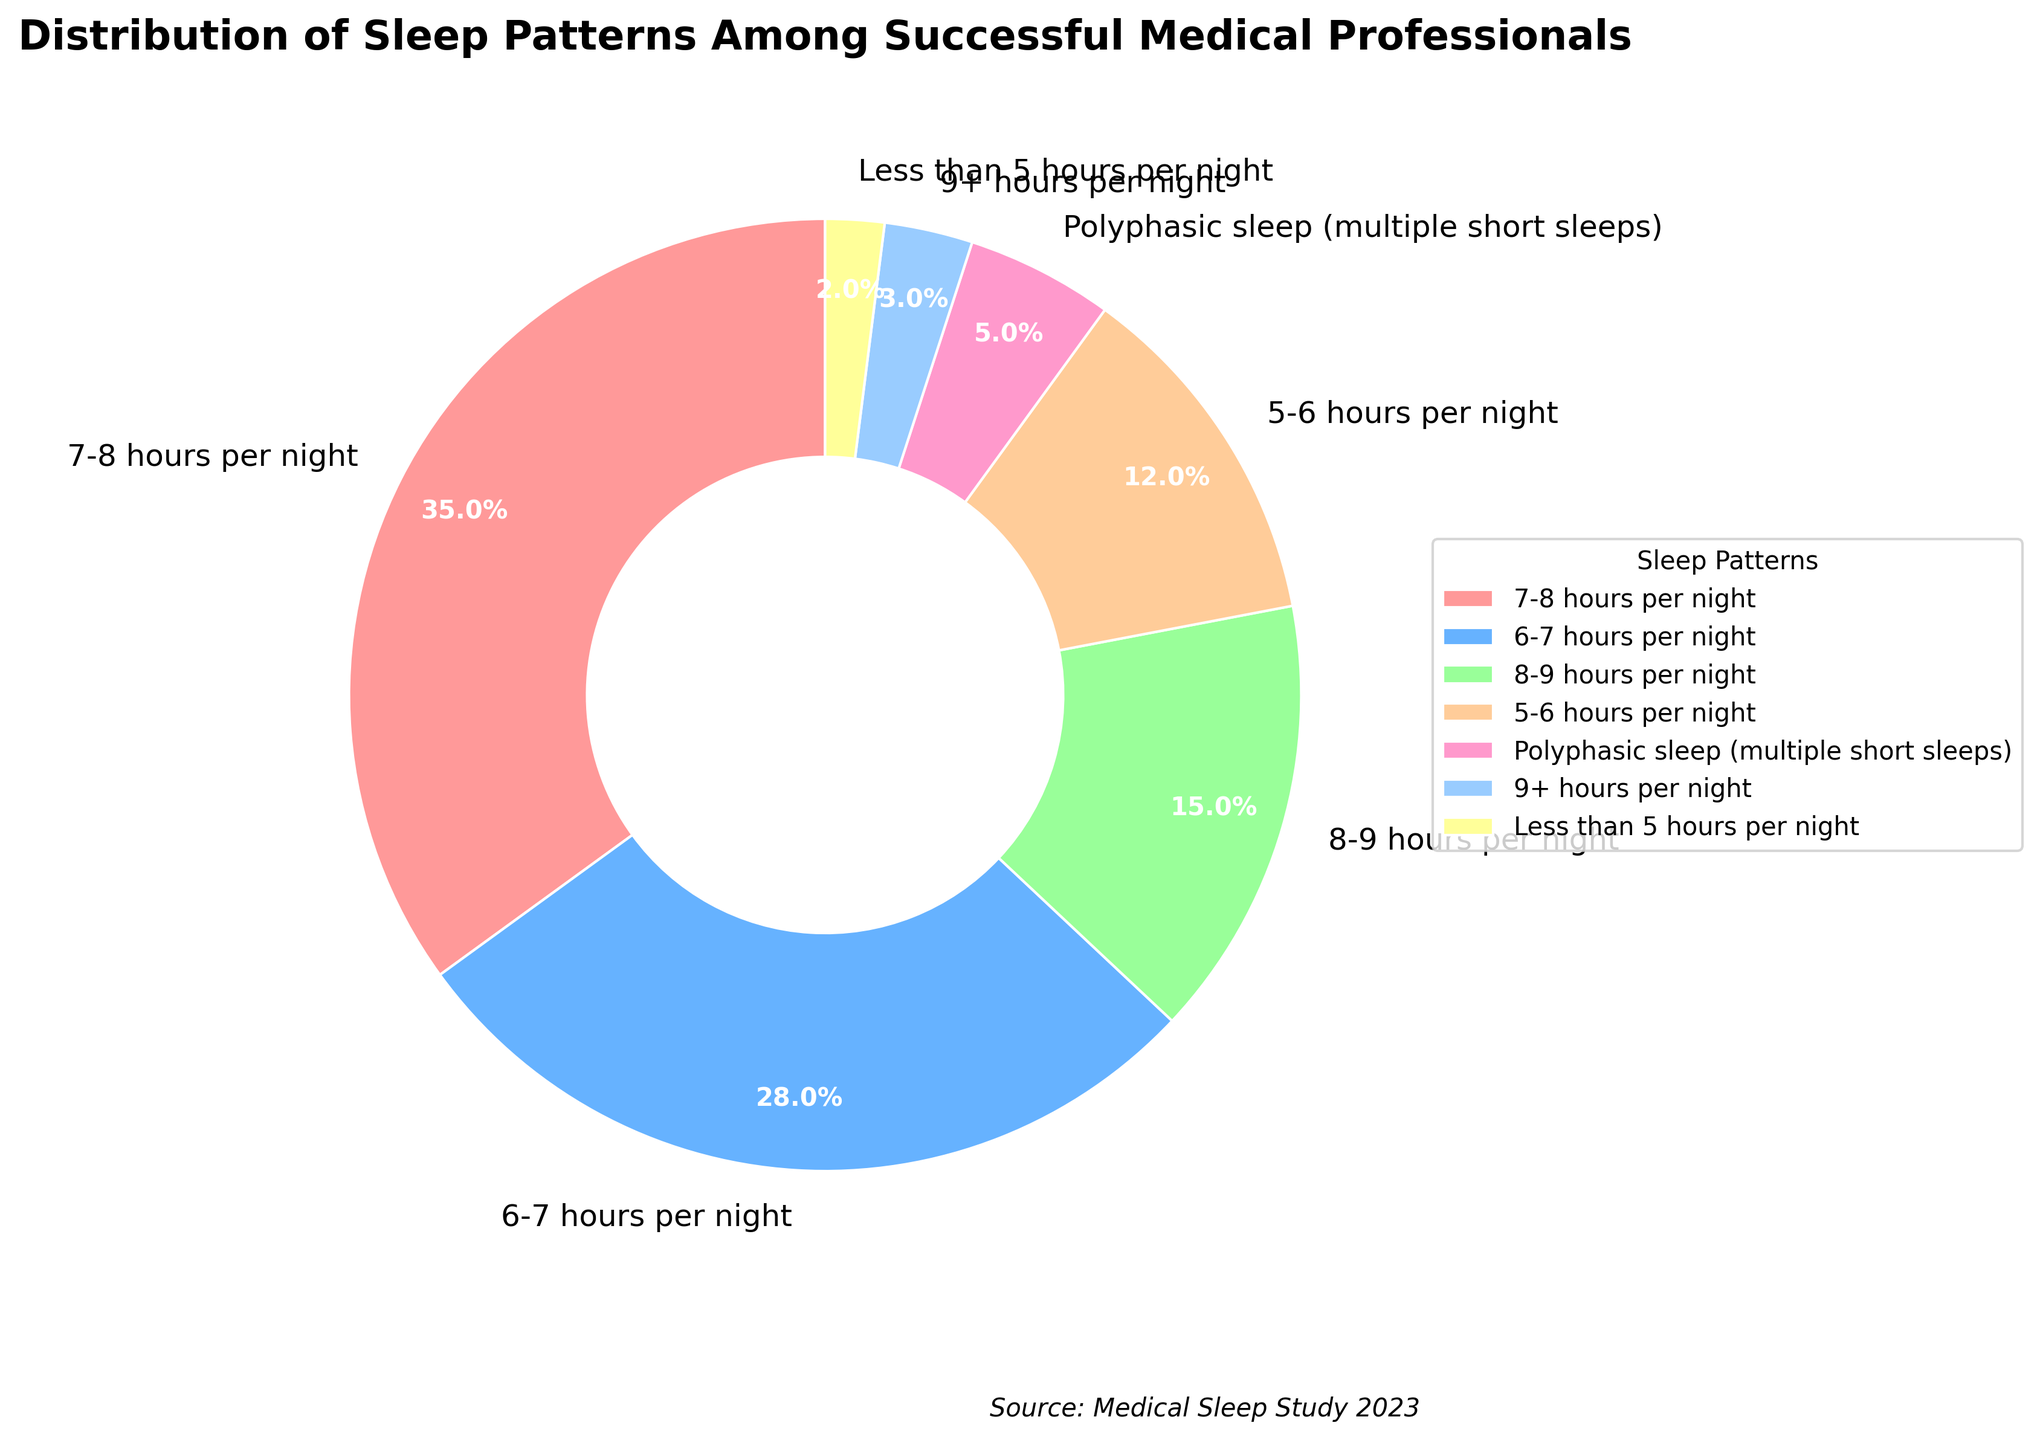Which sleep pattern is the most common among successful medical professionals? The most common sleep pattern is the one with the largest percentage in the pie chart. Observing the chart, the segment labeled "7-8 hours per night" occupies the largest section, indicating it is the most common.
Answer: 7-8 hours per night How many percentage points more sleep do medical professionals get who sleep 7-8 hours per night compared to those who sleep 6-7 hours per night? Subtract the percentage of the "6-7 hours per night" segment from the "7-8 hours per night" segment. 35% - 28% = 7%.
Answer: 7% Which sleep pattern is least common among successful medical professionals? The least common sleep pattern is represented by the smallest segment of the pie chart. The "Less than 5 hours per night" segment is the smallest, indicating it is the least common.
Answer: Less than 5 hours per night What is the combined percentage of medical professionals who sleep either 5-6 hours or less than 5 hours per night? Add the percentages of the "5-6 hours per night" and "Less than 5 hours per night" segments. 12% + 2% = 14%.
Answer: 14% How does the proportion of medical professionals sleeping 9+ hours per night compare to those with polyphasic sleep patterns? Compare the sizes of the segments labeled "9+ hours per night" and "Polyphasic sleep (multiple short sleeps)". The polyphasic sleep segment is larger, with 5%, compared to the 3% for 9+ hours per night.
Answer: More polyphasic sleep What percentage of medical professionals get between 6 and 8 hours of sleep per night (inclusive)? Sum the percentages for the "6-7 hours per night" and "7-8 hours per night" segments. 28% + 35% = 63%.
Answer: 63% How does the pie chart visually distinguish between different sleep patterns with respect to color? Each segment of the pie chart is filled with a distinct color. For example, the "7-8 hours per night" segment is red, and other segments have different colors to differentiate between the sleep patterns visually.
Answer: Different colors Is it more common for successful medical professionals to sleep 8-9 hours per night or less than 5 hours per night? Compare the percentages of the "8-9 hours per night" and "Less than 5 hours per night" segments. "8-9 hours per night" has 15%, which is much larger than the 2% for "Less than 5 hours per night".
Answer: 8-9 hours per night 